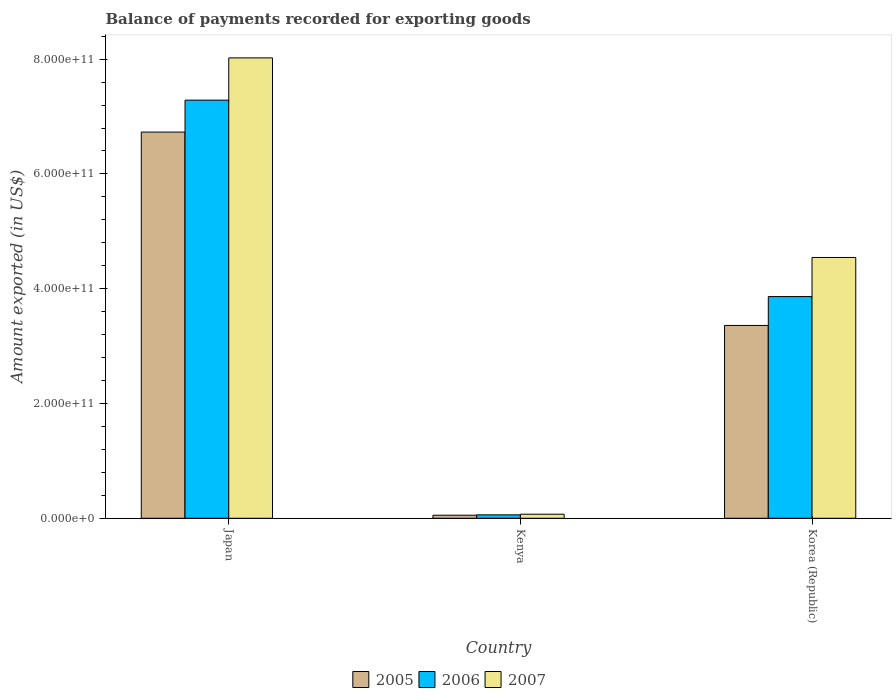Are the number of bars on each tick of the X-axis equal?
Keep it short and to the point. Yes. How many bars are there on the 3rd tick from the right?
Offer a terse response. 3. What is the label of the 2nd group of bars from the left?
Provide a succinct answer. Kenya. In how many cases, is the number of bars for a given country not equal to the number of legend labels?
Your answer should be compact. 0. What is the amount exported in 2007 in Korea (Republic)?
Provide a short and direct response. 4.54e+11. Across all countries, what is the maximum amount exported in 2007?
Give a very brief answer. 8.02e+11. Across all countries, what is the minimum amount exported in 2006?
Provide a short and direct response. 5.95e+09. In which country was the amount exported in 2006 maximum?
Give a very brief answer. Japan. In which country was the amount exported in 2006 minimum?
Your response must be concise. Kenya. What is the total amount exported in 2006 in the graph?
Provide a short and direct response. 1.12e+12. What is the difference between the amount exported in 2006 in Japan and that in Kenya?
Offer a very short reply. 7.23e+11. What is the difference between the amount exported in 2005 in Japan and the amount exported in 2007 in Korea (Republic)?
Provide a succinct answer. 2.19e+11. What is the average amount exported in 2007 per country?
Provide a short and direct response. 4.21e+11. What is the difference between the amount exported of/in 2005 and amount exported of/in 2007 in Kenya?
Your answer should be compact. -1.72e+09. In how many countries, is the amount exported in 2007 greater than 400000000000 US$?
Ensure brevity in your answer.  2. What is the ratio of the amount exported in 2006 in Kenya to that in Korea (Republic)?
Offer a very short reply. 0.02. What is the difference between the highest and the second highest amount exported in 2005?
Your answer should be very brief. 3.37e+11. What is the difference between the highest and the lowest amount exported in 2005?
Offer a terse response. 6.68e+11. Is it the case that in every country, the sum of the amount exported in 2007 and amount exported in 2006 is greater than the amount exported in 2005?
Give a very brief answer. Yes. Are all the bars in the graph horizontal?
Provide a short and direct response. No. What is the difference between two consecutive major ticks on the Y-axis?
Provide a succinct answer. 2.00e+11. Does the graph contain any zero values?
Offer a very short reply. No. Does the graph contain grids?
Provide a succinct answer. No. What is the title of the graph?
Offer a terse response. Balance of payments recorded for exporting goods. What is the label or title of the X-axis?
Your answer should be very brief. Country. What is the label or title of the Y-axis?
Your answer should be very brief. Amount exported (in US$). What is the Amount exported (in US$) in 2005 in Japan?
Ensure brevity in your answer.  6.73e+11. What is the Amount exported (in US$) of 2006 in Japan?
Your answer should be compact. 7.29e+11. What is the Amount exported (in US$) of 2007 in Japan?
Offer a very short reply. 8.02e+11. What is the Amount exported (in US$) of 2005 in Kenya?
Your answer should be very brief. 5.34e+09. What is the Amount exported (in US$) of 2006 in Kenya?
Offer a terse response. 5.95e+09. What is the Amount exported (in US$) of 2007 in Kenya?
Your answer should be compact. 7.06e+09. What is the Amount exported (in US$) in 2005 in Korea (Republic)?
Make the answer very short. 3.36e+11. What is the Amount exported (in US$) of 2006 in Korea (Republic)?
Provide a short and direct response. 3.86e+11. What is the Amount exported (in US$) of 2007 in Korea (Republic)?
Keep it short and to the point. 4.54e+11. Across all countries, what is the maximum Amount exported (in US$) in 2005?
Ensure brevity in your answer.  6.73e+11. Across all countries, what is the maximum Amount exported (in US$) of 2006?
Offer a very short reply. 7.29e+11. Across all countries, what is the maximum Amount exported (in US$) in 2007?
Your response must be concise. 8.02e+11. Across all countries, what is the minimum Amount exported (in US$) in 2005?
Provide a short and direct response. 5.34e+09. Across all countries, what is the minimum Amount exported (in US$) of 2006?
Offer a terse response. 5.95e+09. Across all countries, what is the minimum Amount exported (in US$) in 2007?
Provide a short and direct response. 7.06e+09. What is the total Amount exported (in US$) in 2005 in the graph?
Your answer should be very brief. 1.01e+12. What is the total Amount exported (in US$) in 2006 in the graph?
Offer a very short reply. 1.12e+12. What is the total Amount exported (in US$) of 2007 in the graph?
Offer a terse response. 1.26e+12. What is the difference between the Amount exported (in US$) in 2005 in Japan and that in Kenya?
Your answer should be very brief. 6.68e+11. What is the difference between the Amount exported (in US$) in 2006 in Japan and that in Kenya?
Provide a succinct answer. 7.23e+11. What is the difference between the Amount exported (in US$) of 2007 in Japan and that in Kenya?
Ensure brevity in your answer.  7.95e+11. What is the difference between the Amount exported (in US$) in 2005 in Japan and that in Korea (Republic)?
Ensure brevity in your answer.  3.37e+11. What is the difference between the Amount exported (in US$) of 2006 in Japan and that in Korea (Republic)?
Keep it short and to the point. 3.42e+11. What is the difference between the Amount exported (in US$) in 2007 in Japan and that in Korea (Republic)?
Give a very brief answer. 3.48e+11. What is the difference between the Amount exported (in US$) of 2005 in Kenya and that in Korea (Republic)?
Give a very brief answer. -3.31e+11. What is the difference between the Amount exported (in US$) in 2006 in Kenya and that in Korea (Republic)?
Make the answer very short. -3.80e+11. What is the difference between the Amount exported (in US$) in 2007 in Kenya and that in Korea (Republic)?
Your answer should be very brief. -4.47e+11. What is the difference between the Amount exported (in US$) of 2005 in Japan and the Amount exported (in US$) of 2006 in Kenya?
Your response must be concise. 6.67e+11. What is the difference between the Amount exported (in US$) of 2005 in Japan and the Amount exported (in US$) of 2007 in Kenya?
Keep it short and to the point. 6.66e+11. What is the difference between the Amount exported (in US$) in 2006 in Japan and the Amount exported (in US$) in 2007 in Kenya?
Give a very brief answer. 7.22e+11. What is the difference between the Amount exported (in US$) in 2005 in Japan and the Amount exported (in US$) in 2006 in Korea (Republic)?
Give a very brief answer. 2.87e+11. What is the difference between the Amount exported (in US$) in 2005 in Japan and the Amount exported (in US$) in 2007 in Korea (Republic)?
Provide a short and direct response. 2.19e+11. What is the difference between the Amount exported (in US$) in 2006 in Japan and the Amount exported (in US$) in 2007 in Korea (Republic)?
Make the answer very short. 2.74e+11. What is the difference between the Amount exported (in US$) in 2005 in Kenya and the Amount exported (in US$) in 2006 in Korea (Republic)?
Offer a very short reply. -3.81e+11. What is the difference between the Amount exported (in US$) of 2005 in Kenya and the Amount exported (in US$) of 2007 in Korea (Republic)?
Give a very brief answer. -4.49e+11. What is the difference between the Amount exported (in US$) in 2006 in Kenya and the Amount exported (in US$) in 2007 in Korea (Republic)?
Provide a succinct answer. -4.48e+11. What is the average Amount exported (in US$) in 2005 per country?
Offer a terse response. 3.38e+11. What is the average Amount exported (in US$) in 2006 per country?
Your answer should be very brief. 3.74e+11. What is the average Amount exported (in US$) of 2007 per country?
Provide a short and direct response. 4.21e+11. What is the difference between the Amount exported (in US$) in 2005 and Amount exported (in US$) in 2006 in Japan?
Provide a short and direct response. -5.56e+1. What is the difference between the Amount exported (in US$) in 2005 and Amount exported (in US$) in 2007 in Japan?
Make the answer very short. -1.29e+11. What is the difference between the Amount exported (in US$) of 2006 and Amount exported (in US$) of 2007 in Japan?
Your answer should be compact. -7.36e+1. What is the difference between the Amount exported (in US$) in 2005 and Amount exported (in US$) in 2006 in Kenya?
Ensure brevity in your answer.  -6.04e+08. What is the difference between the Amount exported (in US$) of 2005 and Amount exported (in US$) of 2007 in Kenya?
Make the answer very short. -1.72e+09. What is the difference between the Amount exported (in US$) of 2006 and Amount exported (in US$) of 2007 in Kenya?
Offer a terse response. -1.12e+09. What is the difference between the Amount exported (in US$) of 2005 and Amount exported (in US$) of 2006 in Korea (Republic)?
Provide a short and direct response. -5.03e+1. What is the difference between the Amount exported (in US$) of 2005 and Amount exported (in US$) of 2007 in Korea (Republic)?
Give a very brief answer. -1.18e+11. What is the difference between the Amount exported (in US$) of 2006 and Amount exported (in US$) of 2007 in Korea (Republic)?
Provide a short and direct response. -6.81e+1. What is the ratio of the Amount exported (in US$) in 2005 in Japan to that in Kenya?
Your answer should be very brief. 125.97. What is the ratio of the Amount exported (in US$) in 2006 in Japan to that in Kenya?
Provide a short and direct response. 122.53. What is the ratio of the Amount exported (in US$) in 2007 in Japan to that in Kenya?
Make the answer very short. 113.58. What is the ratio of the Amount exported (in US$) in 2005 in Japan to that in Korea (Republic)?
Your answer should be compact. 2. What is the ratio of the Amount exported (in US$) in 2006 in Japan to that in Korea (Republic)?
Offer a terse response. 1.89. What is the ratio of the Amount exported (in US$) of 2007 in Japan to that in Korea (Republic)?
Offer a very short reply. 1.77. What is the ratio of the Amount exported (in US$) in 2005 in Kenya to that in Korea (Republic)?
Your answer should be compact. 0.02. What is the ratio of the Amount exported (in US$) of 2006 in Kenya to that in Korea (Republic)?
Provide a short and direct response. 0.02. What is the ratio of the Amount exported (in US$) of 2007 in Kenya to that in Korea (Republic)?
Offer a very short reply. 0.02. What is the difference between the highest and the second highest Amount exported (in US$) of 2005?
Provide a succinct answer. 3.37e+11. What is the difference between the highest and the second highest Amount exported (in US$) in 2006?
Provide a succinct answer. 3.42e+11. What is the difference between the highest and the second highest Amount exported (in US$) in 2007?
Provide a short and direct response. 3.48e+11. What is the difference between the highest and the lowest Amount exported (in US$) of 2005?
Keep it short and to the point. 6.68e+11. What is the difference between the highest and the lowest Amount exported (in US$) of 2006?
Your response must be concise. 7.23e+11. What is the difference between the highest and the lowest Amount exported (in US$) of 2007?
Offer a terse response. 7.95e+11. 